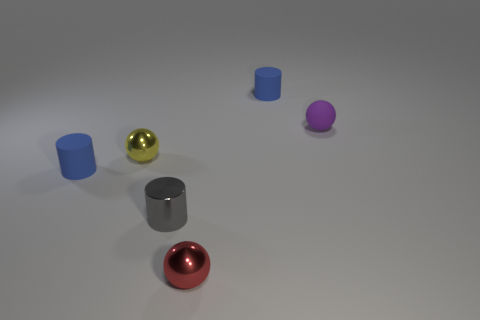How do the objects' colors contribute to the overall composition of the image? The vivid colors of the objects, against the neutral background, create a visually interesting contrast. It gives the scene a playful and dynamic ambiance, drawing attention to each object's shape and form. 